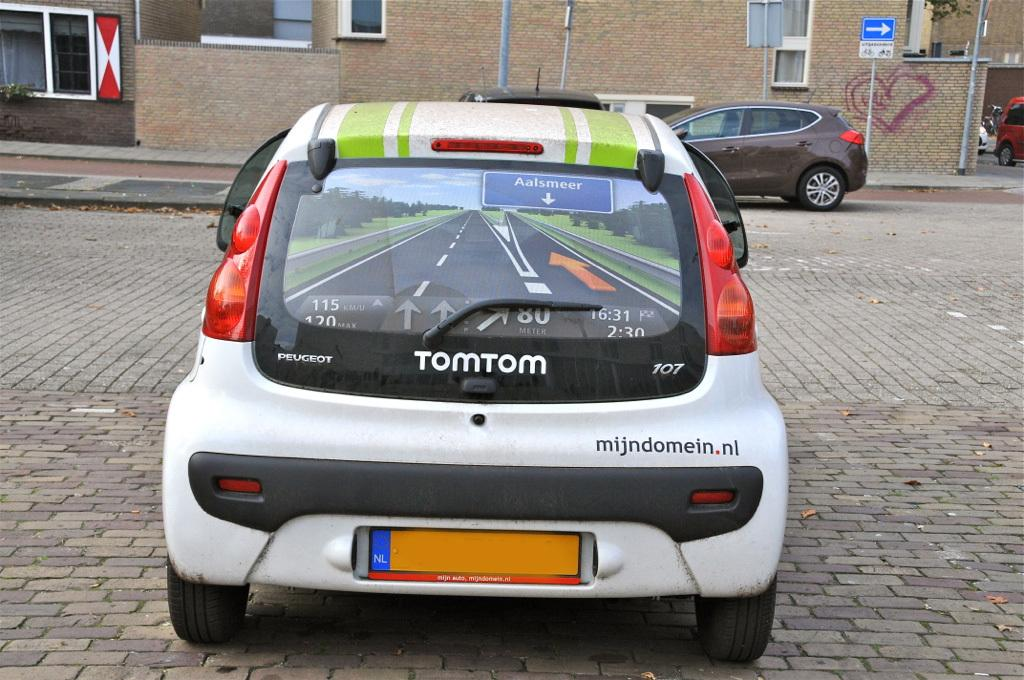What is happening in the middle of the image? There are vehicles on the road in the image. Can you describe the location of the vehicles? The vehicles are in the middle of the image. What else can be seen in the image besides the vehicles? There are poles visible in the image, as well as sign boards and buildings in the background. What type of crack can be seen on the road in the image? There is no crack visible on the road in the image. Can you describe the behavior of the ants in the image? There are no ants present in the image. 